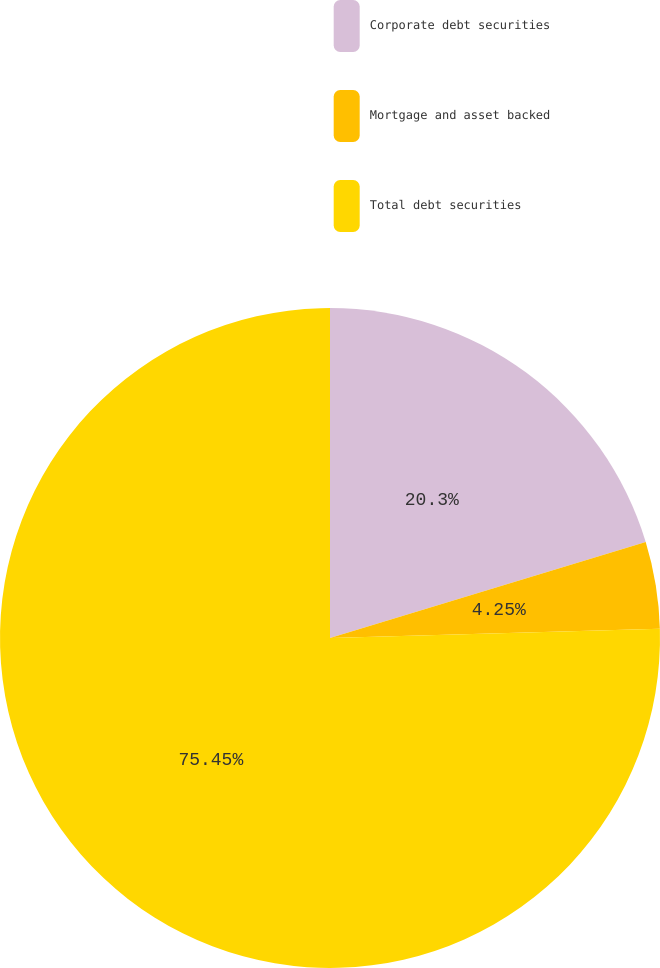Convert chart. <chart><loc_0><loc_0><loc_500><loc_500><pie_chart><fcel>Corporate debt securities<fcel>Mortgage and asset backed<fcel>Total debt securities<nl><fcel>20.3%<fcel>4.25%<fcel>75.45%<nl></chart> 